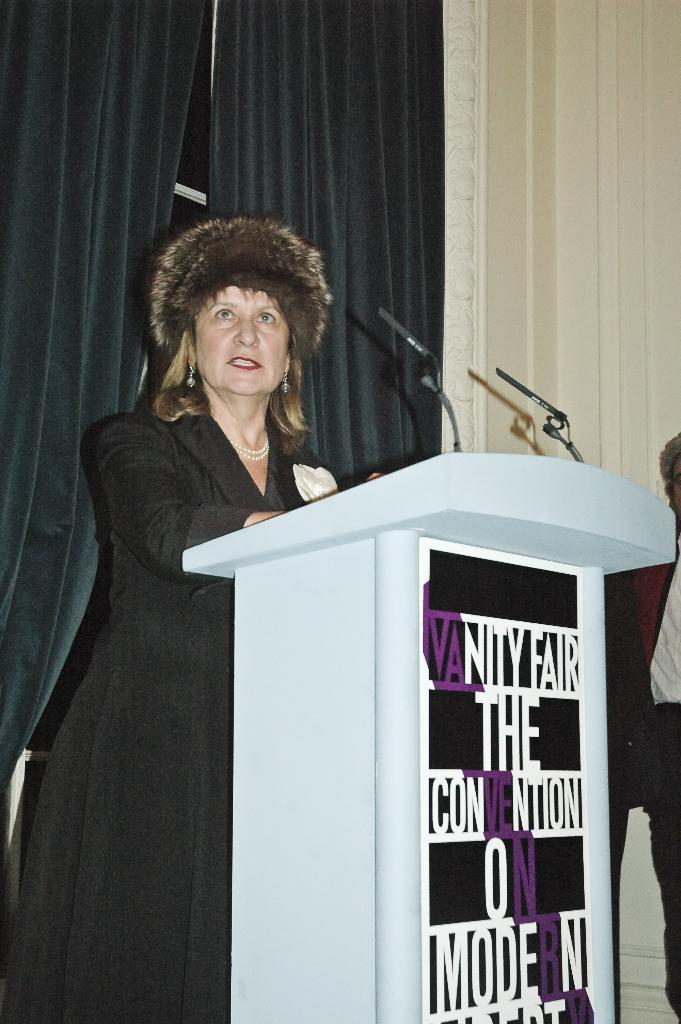How many people are in the image? There are people in the image, but the exact number is not specified. What can be seen hanging near the people in the image? There are curtains in the image. What is the person near the podium doing? The person is standing near a podium and speaking into a microphone. What is written on the podium? There is text on the podium. Can you see a snail crawling on the curtains in the image? No, there is no snail present in the image. What type of leaf is visible on the podium in the image? There are no leaves visible in the image; only text is present on the podium. 